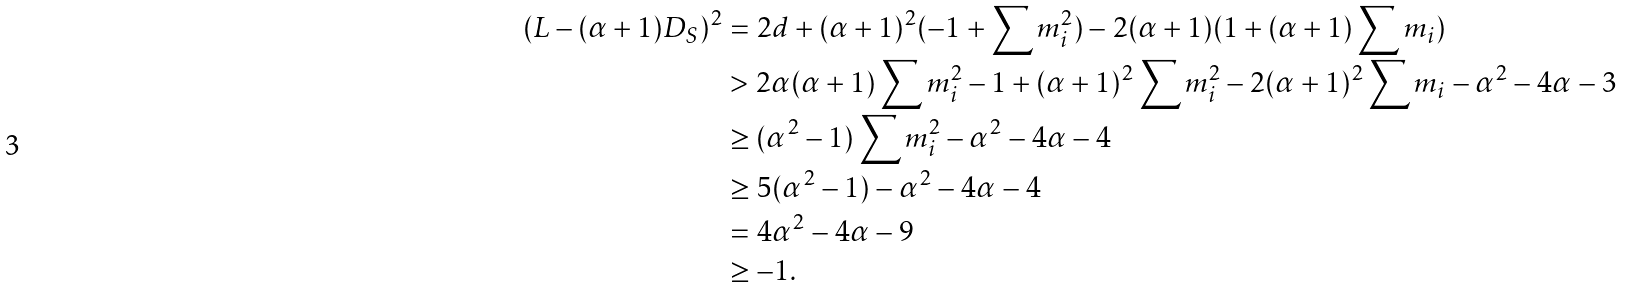<formula> <loc_0><loc_0><loc_500><loc_500>( L - ( \alpha + 1 ) D _ { S } ) ^ { 2 } & = 2 d + ( \alpha + 1 ) ^ { 2 } ( - 1 + \sum m _ { i } ^ { 2 } ) - 2 ( \alpha + 1 ) ( 1 + ( \alpha + 1 ) \sum m _ { i } ) \\ & > 2 \alpha ( \alpha + 1 ) \sum m _ { i } ^ { 2 } - 1 + ( \alpha + 1 ) ^ { 2 } \sum m _ { i } ^ { 2 } - 2 ( \alpha + 1 ) ^ { 2 } \sum m _ { i } - \alpha ^ { 2 } - 4 \alpha - 3 \\ & \geq ( \alpha ^ { 2 } - 1 ) \sum m _ { i } ^ { 2 } - \alpha ^ { 2 } - 4 \alpha - 4 \\ & \geq 5 ( \alpha ^ { 2 } - 1 ) - \alpha ^ { 2 } - 4 \alpha - 4 \\ & = 4 \alpha ^ { 2 } - 4 \alpha - 9 \\ & \geq - 1 .</formula> 